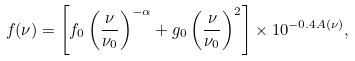<formula> <loc_0><loc_0><loc_500><loc_500>f ( \nu ) = \left [ f _ { 0 } \left ( \frac { \nu } { \nu _ { 0 } } \right ) ^ { - \alpha } + g _ { 0 } \left ( \frac { \nu } { \nu _ { 0 } } \right ) ^ { 2 } \right ] \times 1 0 ^ { - 0 . 4 A ( \nu ) } ,</formula> 